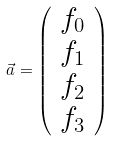<formula> <loc_0><loc_0><loc_500><loc_500>\vec { a } = \left ( \begin{array} { c } f _ { 0 } \\ f _ { 1 } \\ f _ { 2 } \\ f _ { 3 } \end{array} \right )</formula> 